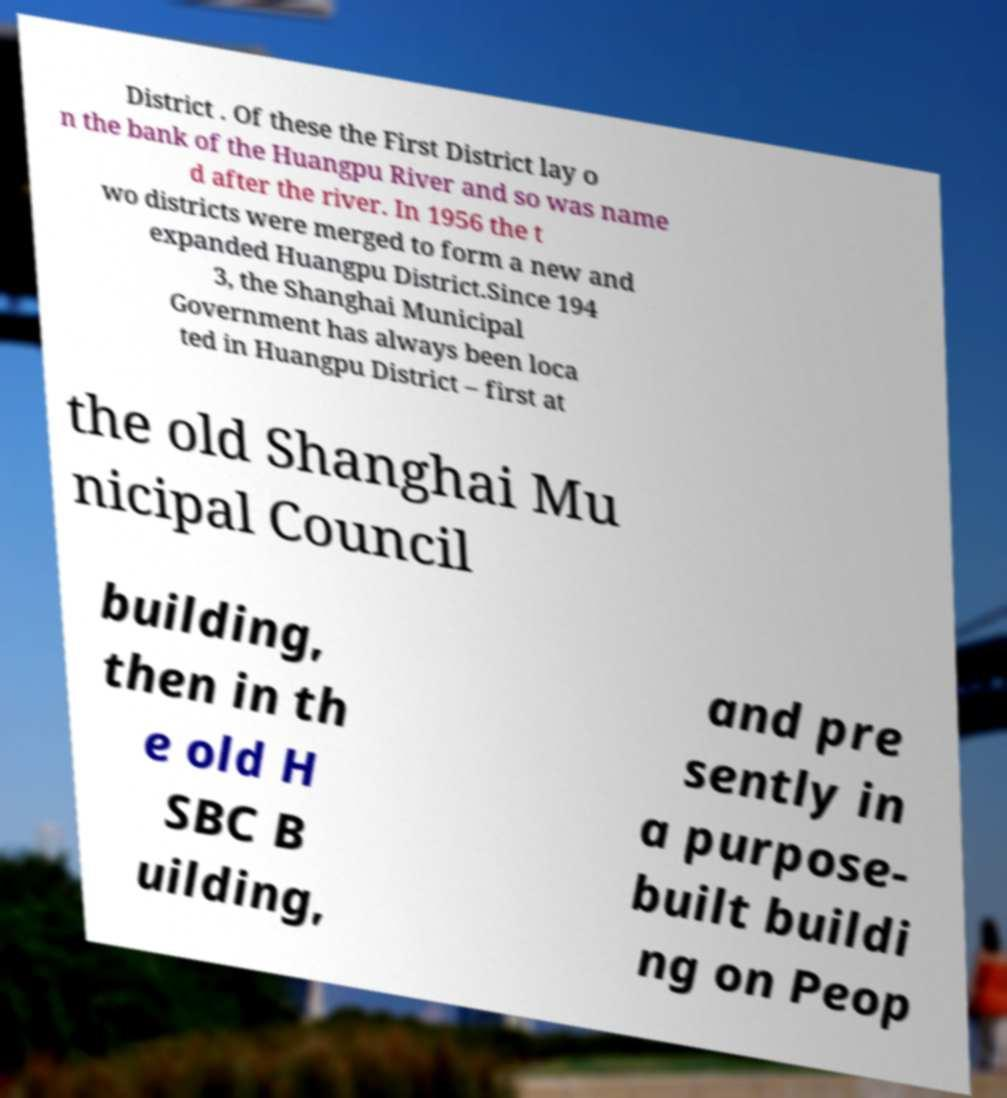Please read and relay the text visible in this image. What does it say? District . Of these the First District lay o n the bank of the Huangpu River and so was name d after the river. In 1956 the t wo districts were merged to form a new and expanded Huangpu District.Since 194 3, the Shanghai Municipal Government has always been loca ted in Huangpu District – first at the old Shanghai Mu nicipal Council building, then in th e old H SBC B uilding, and pre sently in a purpose- built buildi ng on Peop 